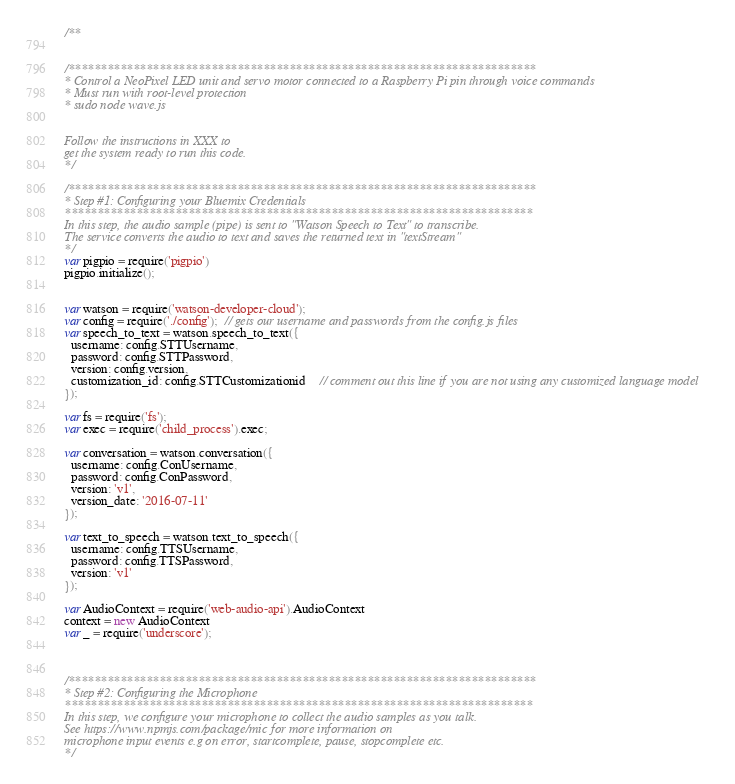<code> <loc_0><loc_0><loc_500><loc_500><_JavaScript_>/**


/************************************************************************
* Control a NeoPixel LED unit and servo motor connected to a Raspberry Pi pin through voice commands
* Must run with root-level protection
* sudo node wave.js


Follow the instructions in XXX to
get the system ready to run this code.
*/

/************************************************************************
* Step #1: Configuring your Bluemix Credentials
************************************************************************
In this step, the audio sample (pipe) is sent to "Watson Speech to Text" to transcribe.
The service converts the audio to text and saves the returned text in "textStream"
*/
var pigpio = require('pigpio')
pigpio.initialize();


var watson = require('watson-developer-cloud');
var config = require('./config');  // gets our username and passwords from the config.js files
var speech_to_text = watson.speech_to_text({
  username: config.STTUsername,
  password: config.STTPassword,
  version: config.version,
  customization_id: config.STTCustomizationid    // comment out this line if you are not using any customized language model
});

var fs = require('fs');
var exec = require('child_process').exec;

var conversation = watson.conversation({
  username: config.ConUsername,
  password: config.ConPassword,
  version: 'v1',
  version_date: '2016-07-11'
});

var text_to_speech = watson.text_to_speech({
  username: config.TTSUsername,
  password: config.TTSPassword,
  version: 'v1'
});

var AudioContext = require('web-audio-api').AudioContext
context = new AudioContext
var _ = require('underscore');



/************************************************************************
* Step #2: Configuring the Microphone
************************************************************************
In this step, we configure your microphone to collect the audio samples as you talk.
See https://www.npmjs.com/package/mic for more information on
microphone input events e.g on error, startcomplete, pause, stopcomplete etc.
*/
</code> 